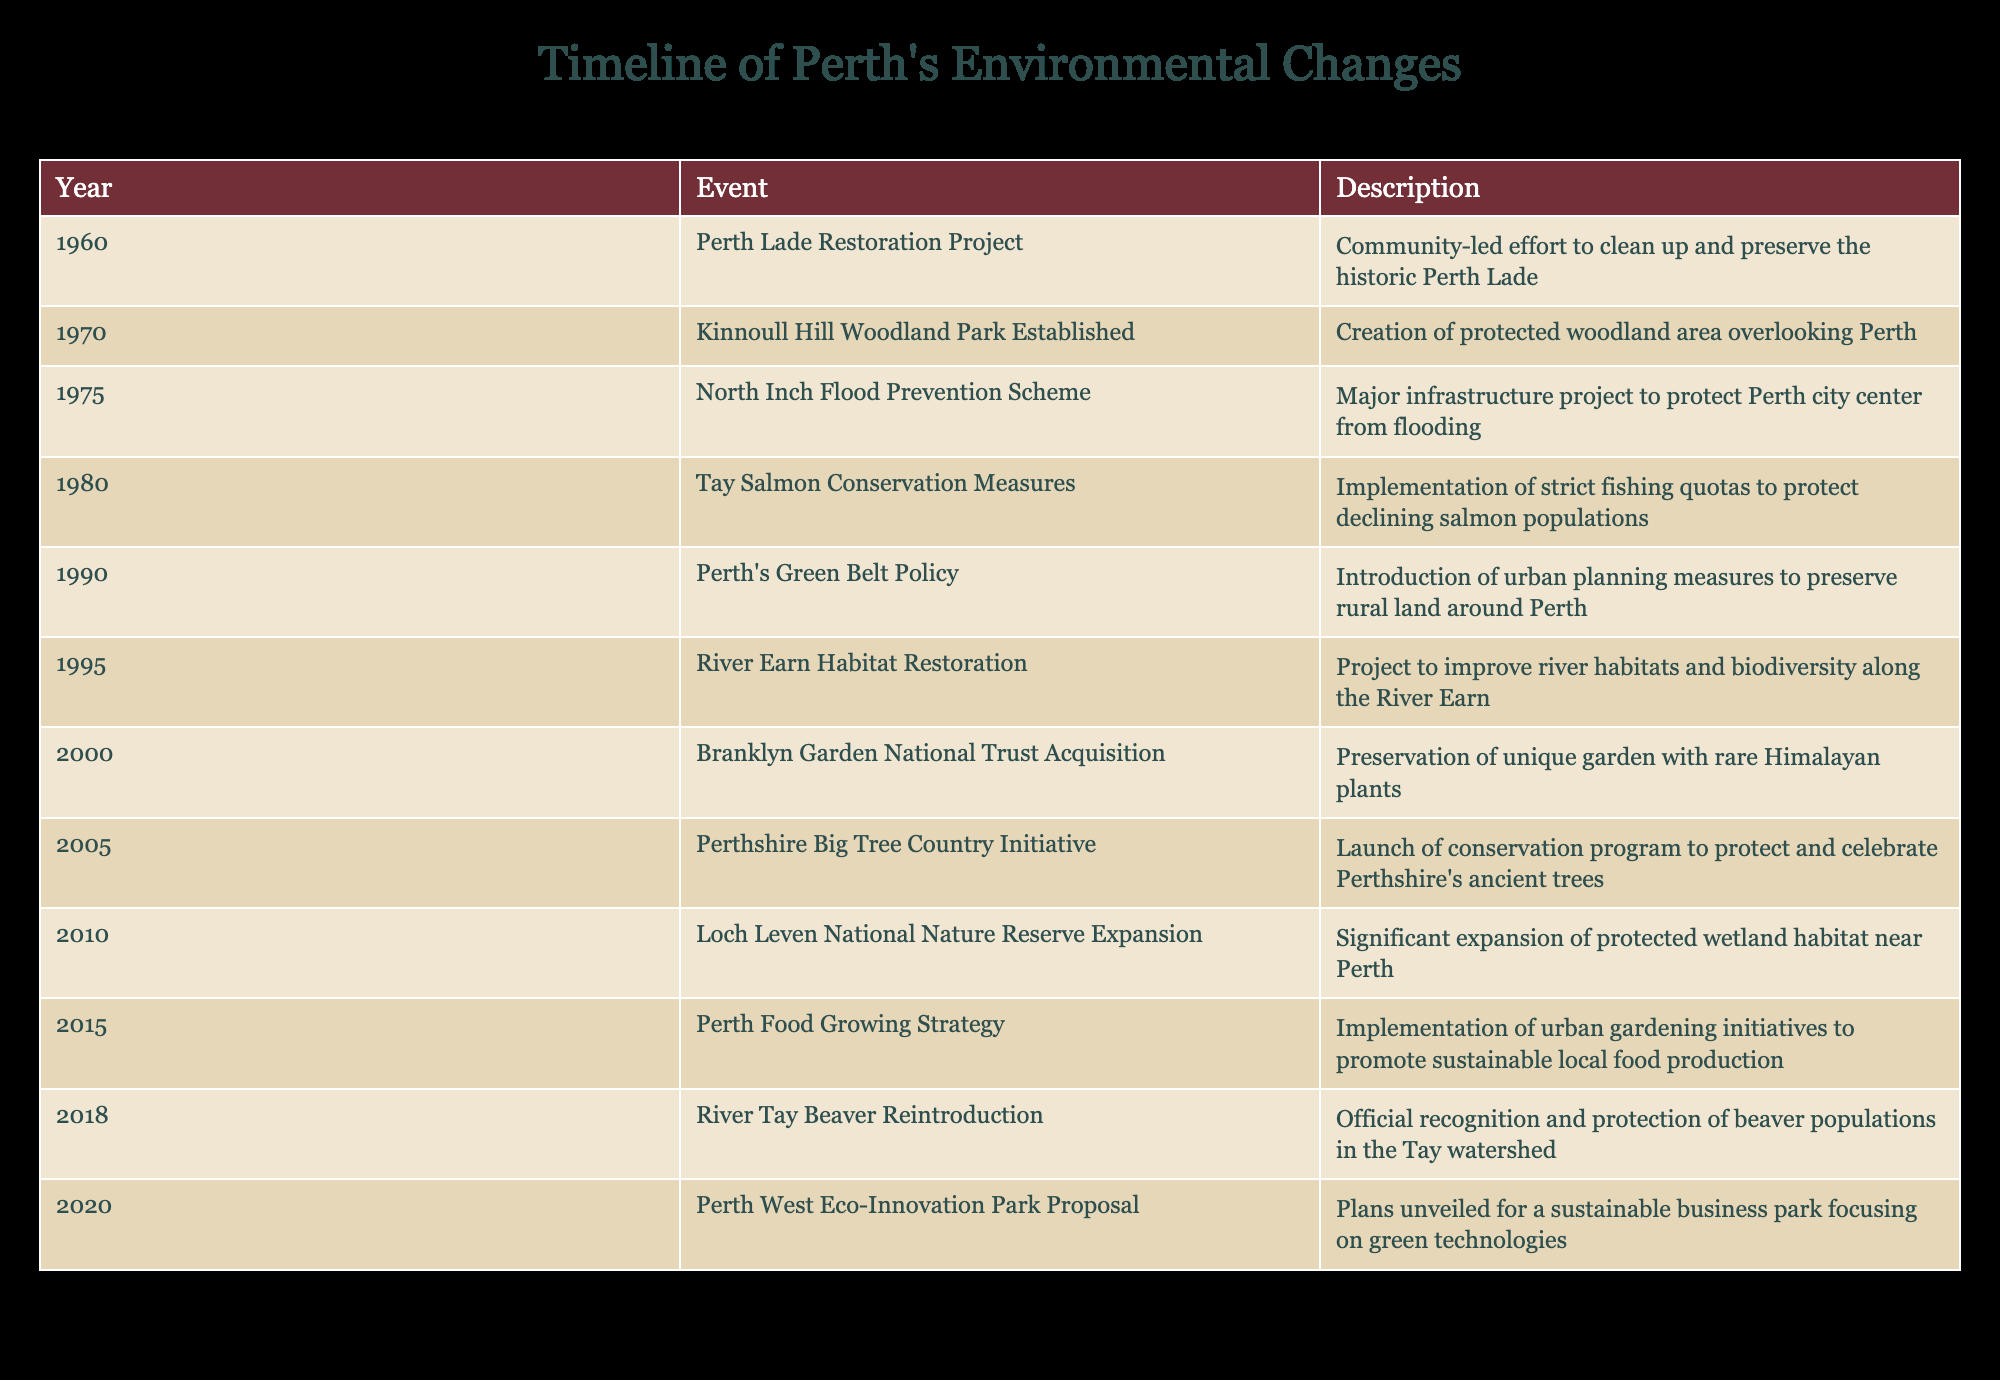What year did the Perth Lade Restoration Project take place? The table lists the event along with its corresponding year. By looking at the row for the "Perth Lade Restoration Project," we can see that it was in the year 1960.
Answer: 1960 What was the main focus of Tay Salmon Conservation Measures in 1980? The table describes the event "Tay Salmon Conservation Measures," indicating that it involved the implementation of strict fishing quotas to protect declining salmon populations.
Answer: To protect declining salmon populations How many events took place in the 1990s? By examining the table, we can find three events listed in the 1990s: Perth's Green Belt Policy in 1990, River Earn Habitat Restoration in 1995, and one additional event, adding to a total of three events in that decade.
Answer: 3 Is the River Earn Habitat Restoration project aimed at improving river habitats? Referring to the description of the “River Earn Habitat Restoration” event, it clearly states that the project's goal is to improve river habitats and biodiversity along the River Earn.
Answer: Yes Which event occurred between the establishment of Kinnoull Hill Woodland Park and the North Inch Flood Prevention Scheme? From the table, Kinnoull Hill Woodland Park was established in 1970, and the North Inch Flood Prevention Scheme took place in 1975. The event that falls between these years is none, as there is only a gap of five years.
Answer: None How does the number of conservation efforts in the 21st century compare to those in the 20th century? In the table, we see seven events listed in the 20th century (from 1960 to 1999) and four events in the 21st century (from 2000 onward). Therefore, there are fewer conservation efforts in the 21st century compared to the 20th century.
Answer: 21st century has fewer efforts What was the last environmental change mentioned in the table? The last event listed in the table is the "Perth West Eco-Innovation Park Proposal," which took place in 2020. This can be confirmed by looking at the last row of the timeline.
Answer: Perth West Eco-Innovation Park Proposal in 2020 What inspired the initiation of the Perth Food Growing Strategy in 2015? The table indicates the "Perth Food Growing Strategy" was implemented to promote sustainable local food production, which shows a focus on urban gardening initiatives inspired by local food sustainability needs.
Answer: Sustainable local food production What percentage of the events are related to habitat restoration? There are three events focused on habitat restoration: Perth Lade Restoration Project in 1960, River Earn Habitat Restoration in 1995, and River Tay Beaver Reintroduction in 2018. With a total of 10 events, the calculation is (3/10)*100=30%.
Answer: 30% 